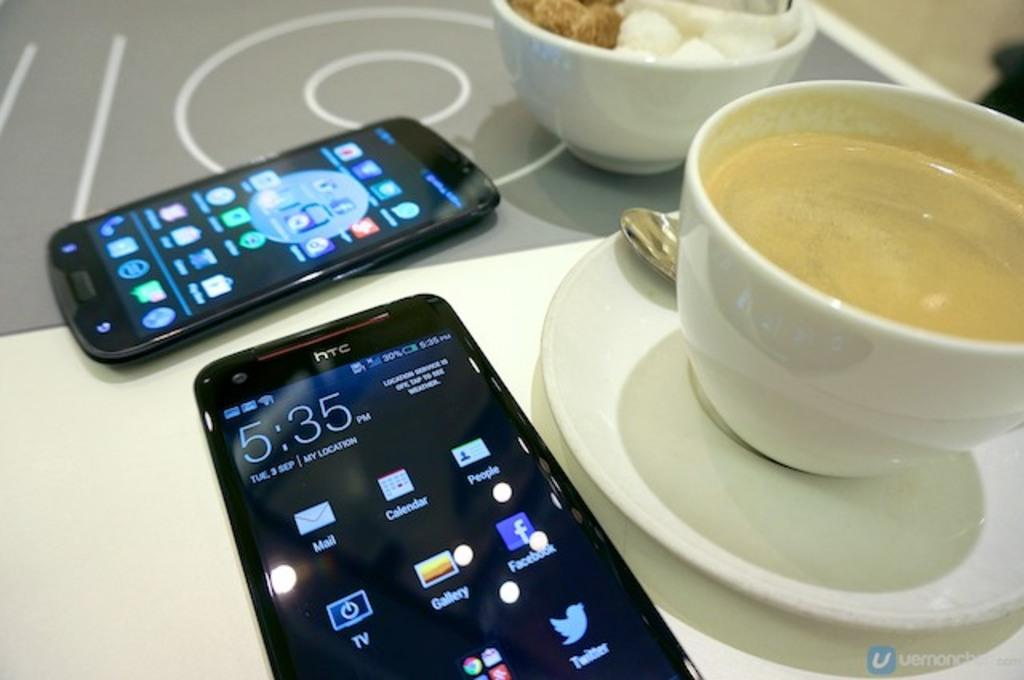<image>
Render a clear and concise summary of the photo. the time on the clock reads 5:35 on the front 